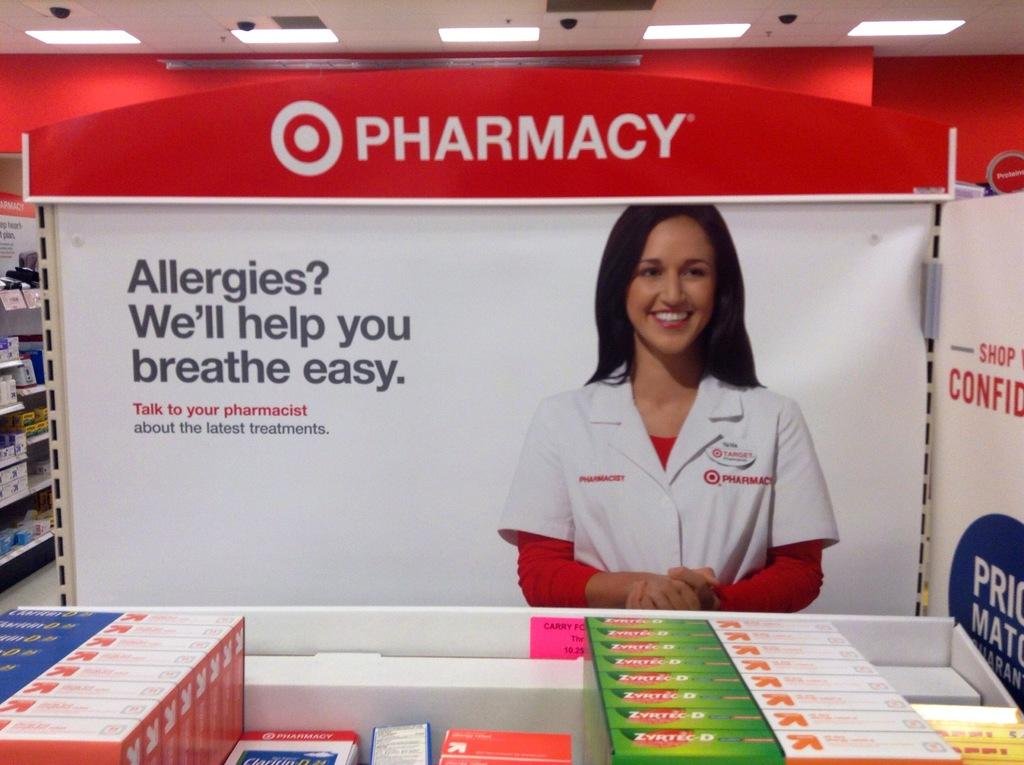<image>
Share a concise interpretation of the image provided. a sign at a Pharmacy talking about allergies 